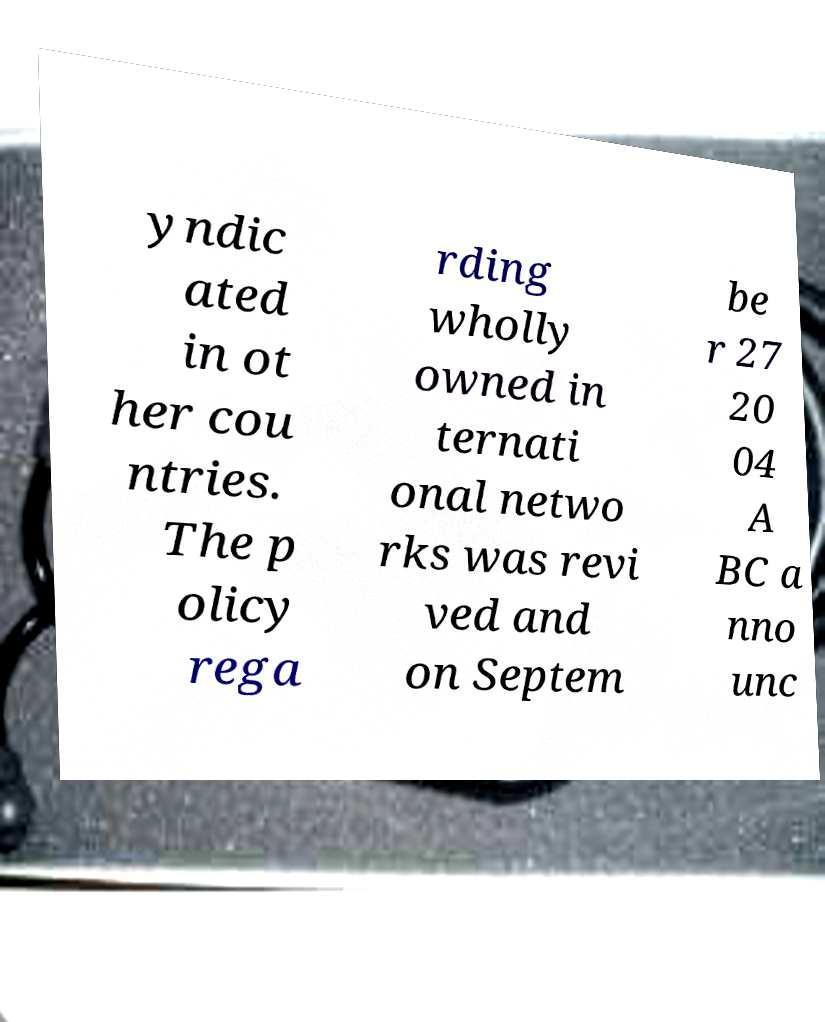I need the written content from this picture converted into text. Can you do that? yndic ated in ot her cou ntries. The p olicy rega rding wholly owned in ternati onal netwo rks was revi ved and on Septem be r 27 20 04 A BC a nno unc 